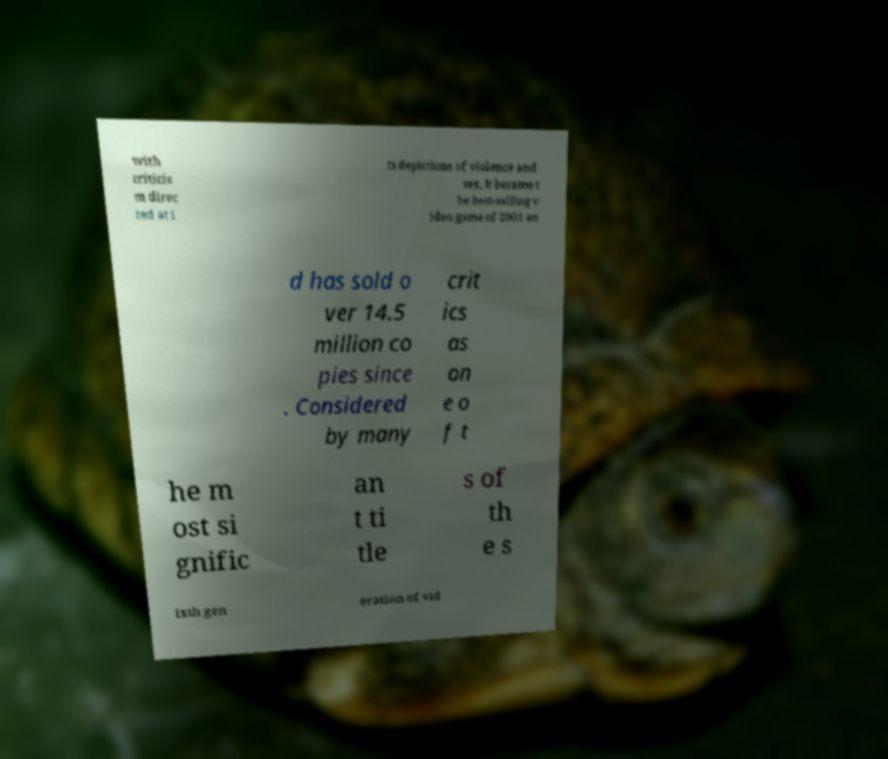For documentation purposes, I need the text within this image transcribed. Could you provide that? with criticis m direc ted at i ts depictions of violence and sex. It became t he best-selling v ideo game of 2001 an d has sold o ver 14.5 million co pies since . Considered by many crit ics as on e o f t he m ost si gnific an t ti tle s of th e s ixth gen eration of vid 